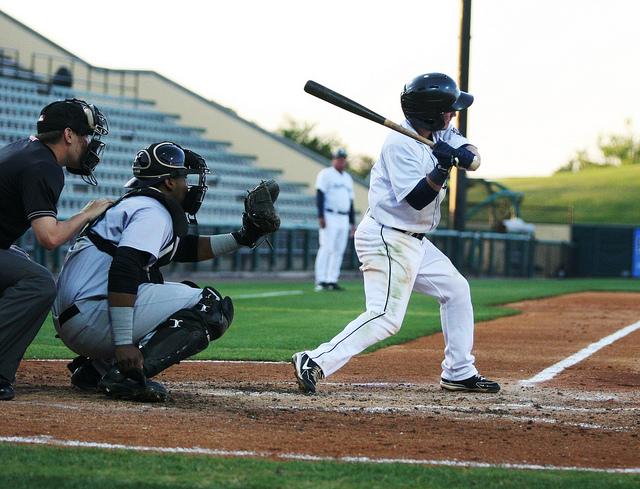How many people are there in the stands?
Answer briefly. 0. Is this baseball player holding a bat?
Be succinct. Yes. What leg is the brace on?
Give a very brief answer. Right. What sport is this?
Quick response, please. Baseball. 